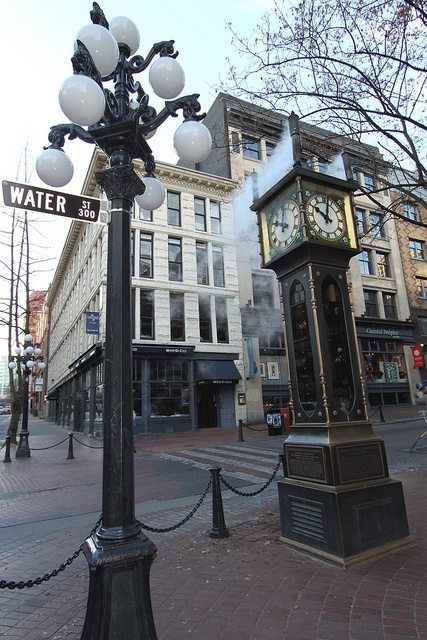Describe the objects in this image and their specific colors. I can see clock in white, gray, darkgray, and lightgray tones and clock in white, darkgray, gray, darkgreen, and black tones in this image. 